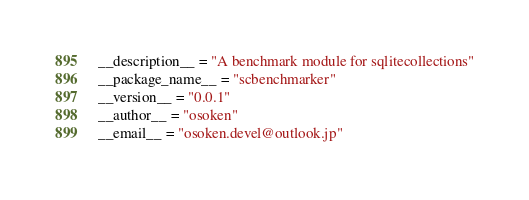<code> <loc_0><loc_0><loc_500><loc_500><_Python_>__description__ = "A benchmark module for sqlitecollections"
__package_name__ = "scbenchmarker"
__version__ = "0.0.1"
__author__ = "osoken"
__email__ = "osoken.devel@outlook.jp"
</code> 